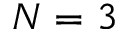Convert formula to latex. <formula><loc_0><loc_0><loc_500><loc_500>N = 3</formula> 